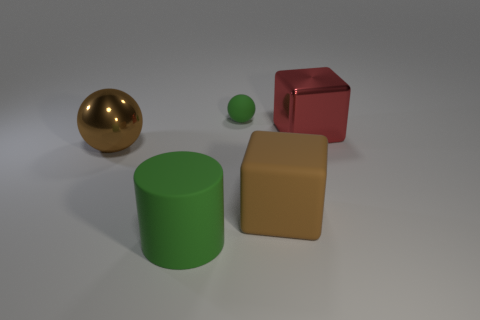Is there anything else that is the same size as the green matte ball?
Give a very brief answer. No. Are there any other things that are the same shape as the big green thing?
Give a very brief answer. No. Are any small green rubber balls visible?
Your response must be concise. Yes. Do the big red object and the brown rubber object have the same shape?
Give a very brief answer. Yes. What number of green cylinders are behind the green thing behind the metal thing left of the red block?
Offer a terse response. 0. What material is the object that is both in front of the big metal sphere and behind the large cylinder?
Offer a terse response. Rubber. The large object that is on the left side of the red block and on the right side of the small green thing is what color?
Your answer should be compact. Brown. Are there any other things that have the same color as the metal cube?
Provide a succinct answer. No. What is the shape of the big brown thing right of the green thing behind the large block that is behind the brown ball?
Keep it short and to the point. Cube. There is another large matte object that is the same shape as the big red thing; what is its color?
Offer a terse response. Brown. 